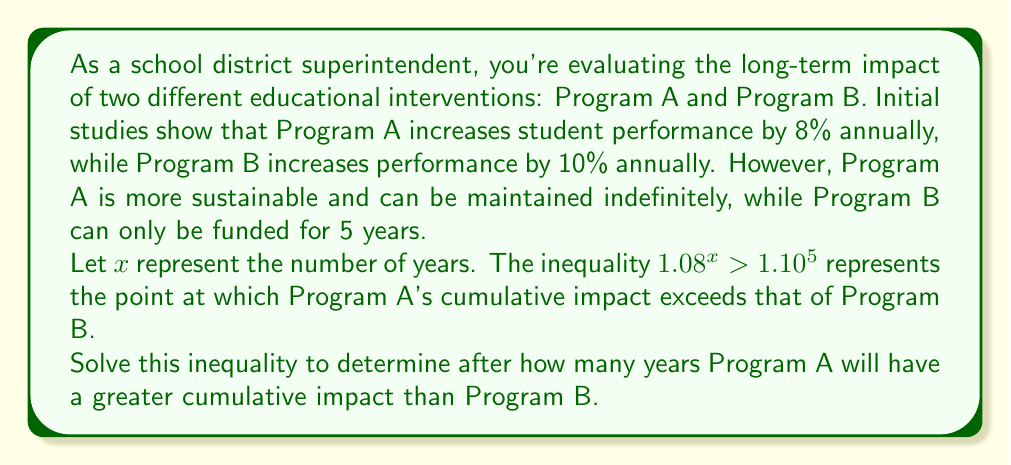Solve this math problem. Let's solve this step-by-step:

1) We start with the inequality:
   $$1.08^x > 1.10^5$$

2) Take the natural logarithm of both sides. Since ln is an increasing function, it preserves the inequality:
   $$\ln(1.08^x) > \ln(1.10^5)$$

3) Using the logarithm property $\ln(a^b) = b\ln(a)$, we get:
   $$x\ln(1.08) > 5\ln(1.10)$$

4) Divide both sides by $\ln(1.08)$. Since $\ln(1.08)$ is positive, the inequality direction remains the same:
   $$x > \frac{5\ln(1.10)}{\ln(1.08)}$$

5) Calculate the right side:
   $$x > \frac{5 * 0.0953}{0.0770} \approx 6.19$$

6) Since $x$ represents years, we need to round up to the next whole number.

Therefore, Program A will have a greater cumulative impact after 7 years.
Answer: Program A will have a greater cumulative impact than Program B after 7 years. 